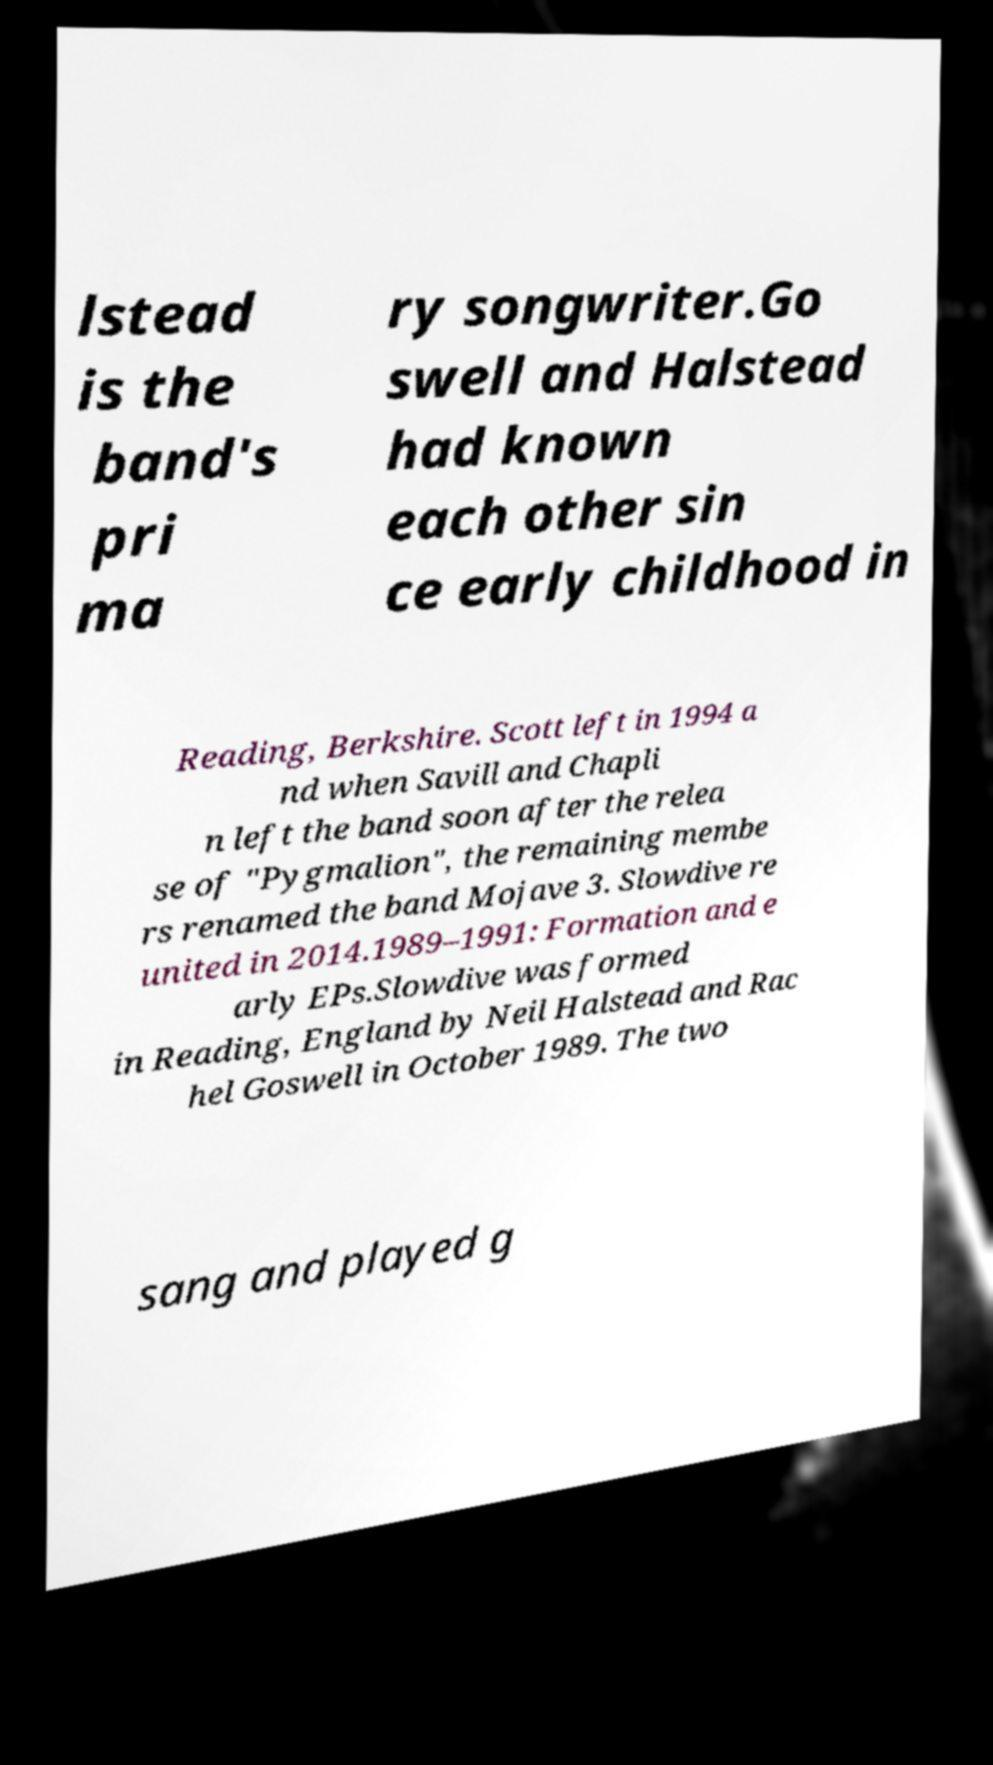For documentation purposes, I need the text within this image transcribed. Could you provide that? lstead is the band's pri ma ry songwriter.Go swell and Halstead had known each other sin ce early childhood in Reading, Berkshire. Scott left in 1994 a nd when Savill and Chapli n left the band soon after the relea se of "Pygmalion", the remaining membe rs renamed the band Mojave 3. Slowdive re united in 2014.1989–1991: Formation and e arly EPs.Slowdive was formed in Reading, England by Neil Halstead and Rac hel Goswell in October 1989. The two sang and played g 